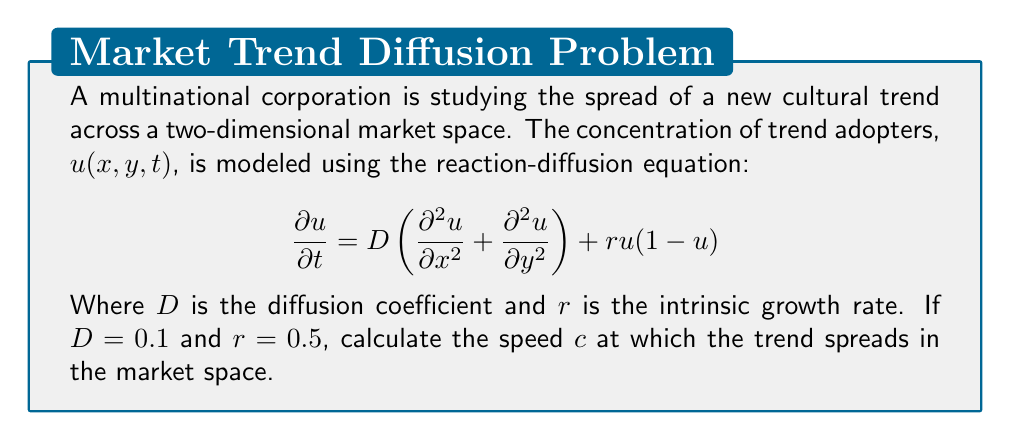Can you answer this question? To solve this problem, we'll follow these steps:

1) The given equation is a Fisher-KPP equation, which is used to model the spread of populations or, in this case, cultural trends.

2) For reaction-diffusion equations of this form, there exists a traveling wave solution that propagates with a constant speed $c$.

3) The speed of propagation for the Fisher-KPP equation is given by the formula:

   $$c = 2\sqrt{rD}$$

4) We are given:
   $D = 0.1$ (diffusion coefficient)
   $r = 0.5$ (intrinsic growth rate)

5) Let's substitute these values into the formula:

   $$c = 2\sqrt{(0.5)(0.1)}$$

6) Simplify under the square root:

   $$c = 2\sqrt{0.05}$$

7) Calculate the square root:

   $$c = 2(0.2236)$$

8) Multiply:

   $$c = 0.4472$$

Therefore, the speed at which the cultural trend spreads in the market space is approximately 0.4472 units per time step.
Answer: $0.4472$ units per time step 